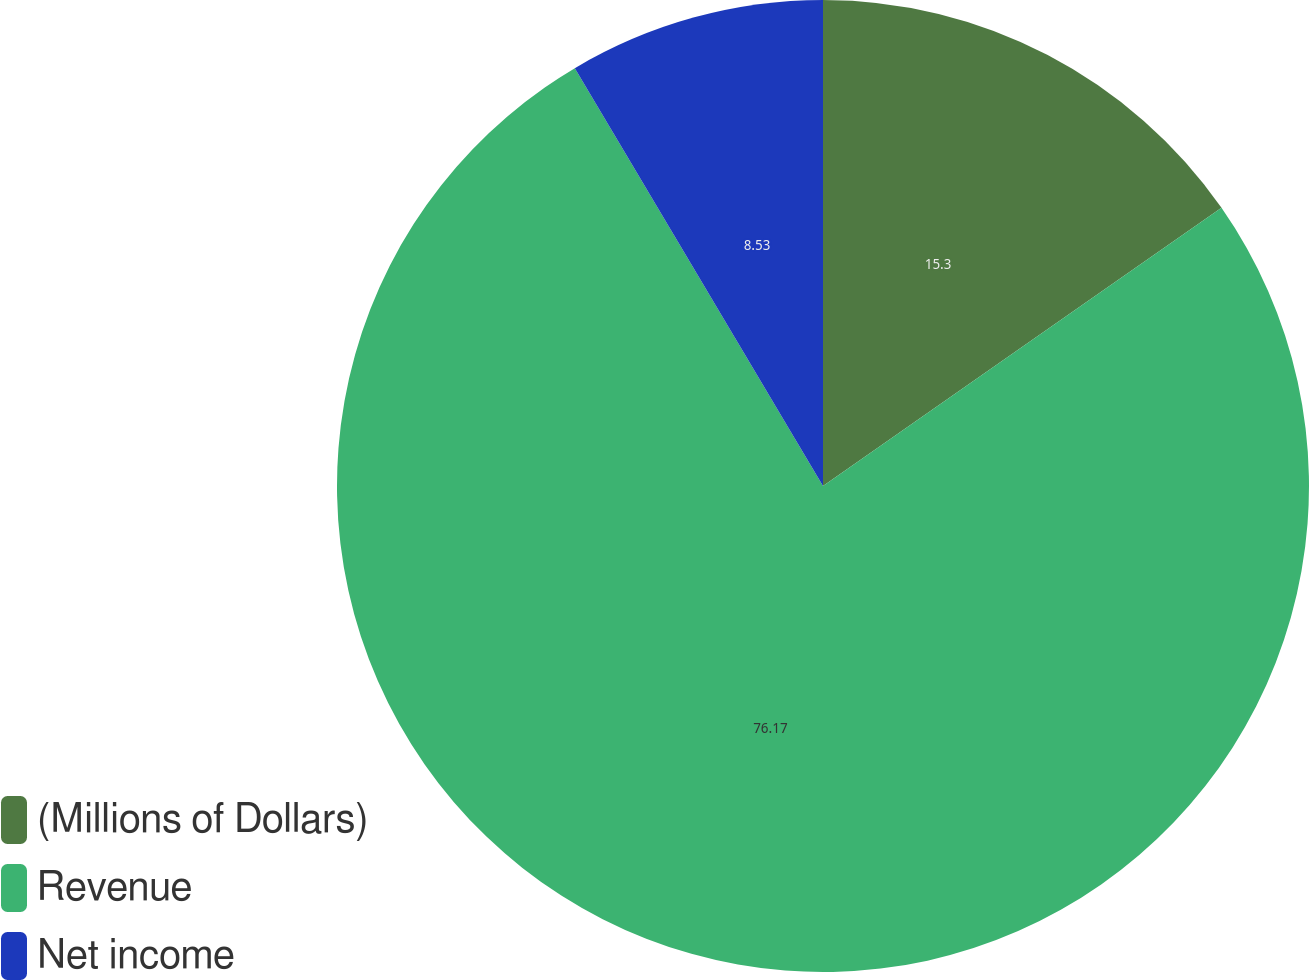Convert chart to OTSL. <chart><loc_0><loc_0><loc_500><loc_500><pie_chart><fcel>(Millions of Dollars)<fcel>Revenue<fcel>Net income<nl><fcel>15.3%<fcel>76.17%<fcel>8.53%<nl></chart> 